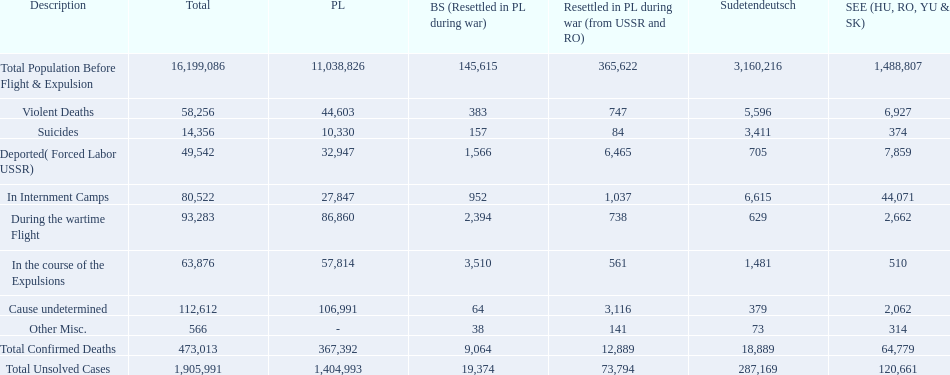Did poland or sudetendeutsch have a higher total population prior to expulsion? Poland. Can you give me this table as a dict? {'header': ['Description', 'Total', 'PL', 'BS (Resettled in PL during war)', 'Resettled in PL during war (from USSR and RO)', 'Sudetendeutsch', 'SEE (HU, RO, YU & SK)'], 'rows': [['Total Population Before Flight & Expulsion', '16,199,086', '11,038,826', '145,615', '365,622', '3,160,216', '1,488,807'], ['Violent Deaths', '58,256', '44,603', '383', '747', '5,596', '6,927'], ['Suicides', '14,356', '10,330', '157', '84', '3,411', '374'], ['Deported( Forced Labor USSR)', '49,542', '32,947', '1,566', '6,465', '705', '7,859'], ['In Internment Camps', '80,522', '27,847', '952', '1,037', '6,615', '44,071'], ['During the wartime Flight', '93,283', '86,860', '2,394', '738', '629', '2,662'], ['In the course of the Expulsions', '63,876', '57,814', '3,510', '561', '1,481', '510'], ['Cause undetermined', '112,612', '106,991', '64', '3,116', '379', '2,062'], ['Other Misc.', '566', '-', '38', '141', '73', '314'], ['Total Confirmed Deaths', '473,013', '367,392', '9,064', '12,889', '18,889', '64,779'], ['Total Unsolved Cases', '1,905,991', '1,404,993', '19,374', '73,794', '287,169', '120,661']]} 